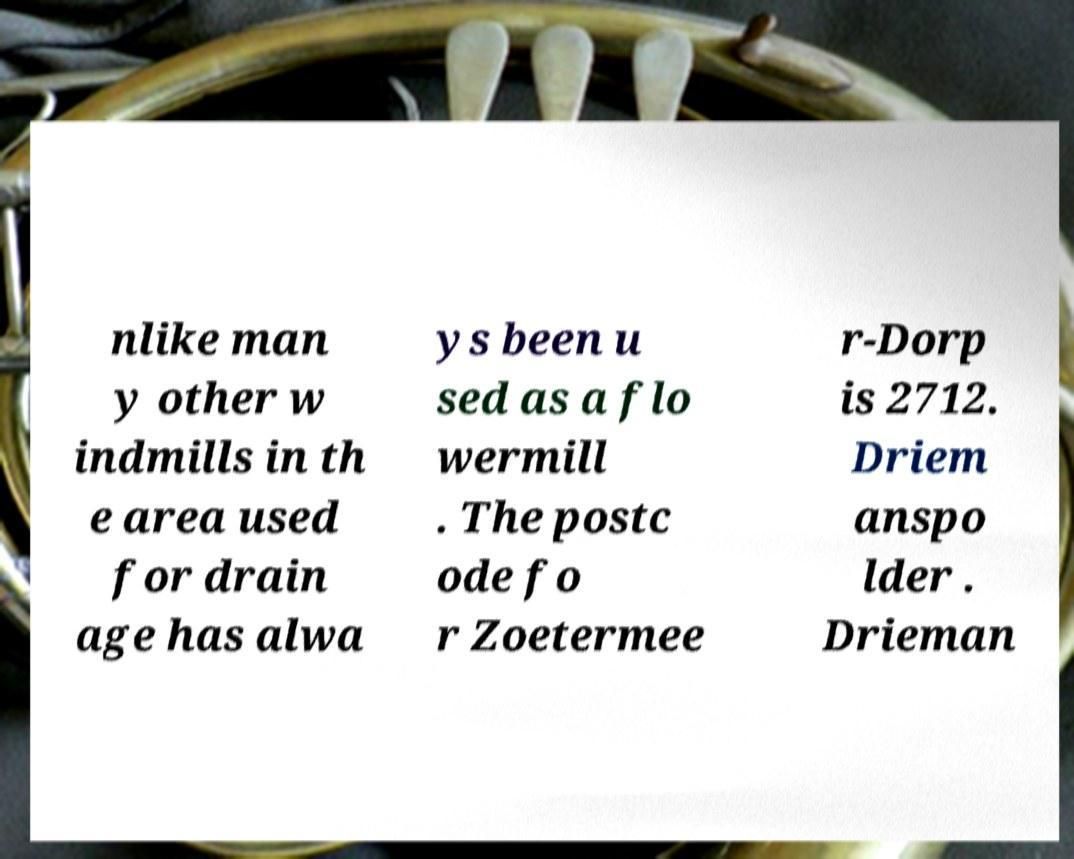For documentation purposes, I need the text within this image transcribed. Could you provide that? nlike man y other w indmills in th e area used for drain age has alwa ys been u sed as a flo wermill . The postc ode fo r Zoetermee r-Dorp is 2712. Driem anspo lder . Drieman 